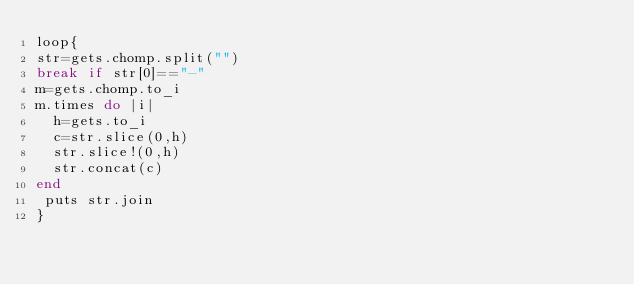Convert code to text. <code><loc_0><loc_0><loc_500><loc_500><_Ruby_>loop{
str=gets.chomp.split("")
break if str[0]=="-"
m=gets.chomp.to_i
m.times do |i|
  h=gets.to_i
  c=str.slice(0,h)
  str.slice!(0,h)
  str.concat(c)
end
 puts str.join
}</code> 